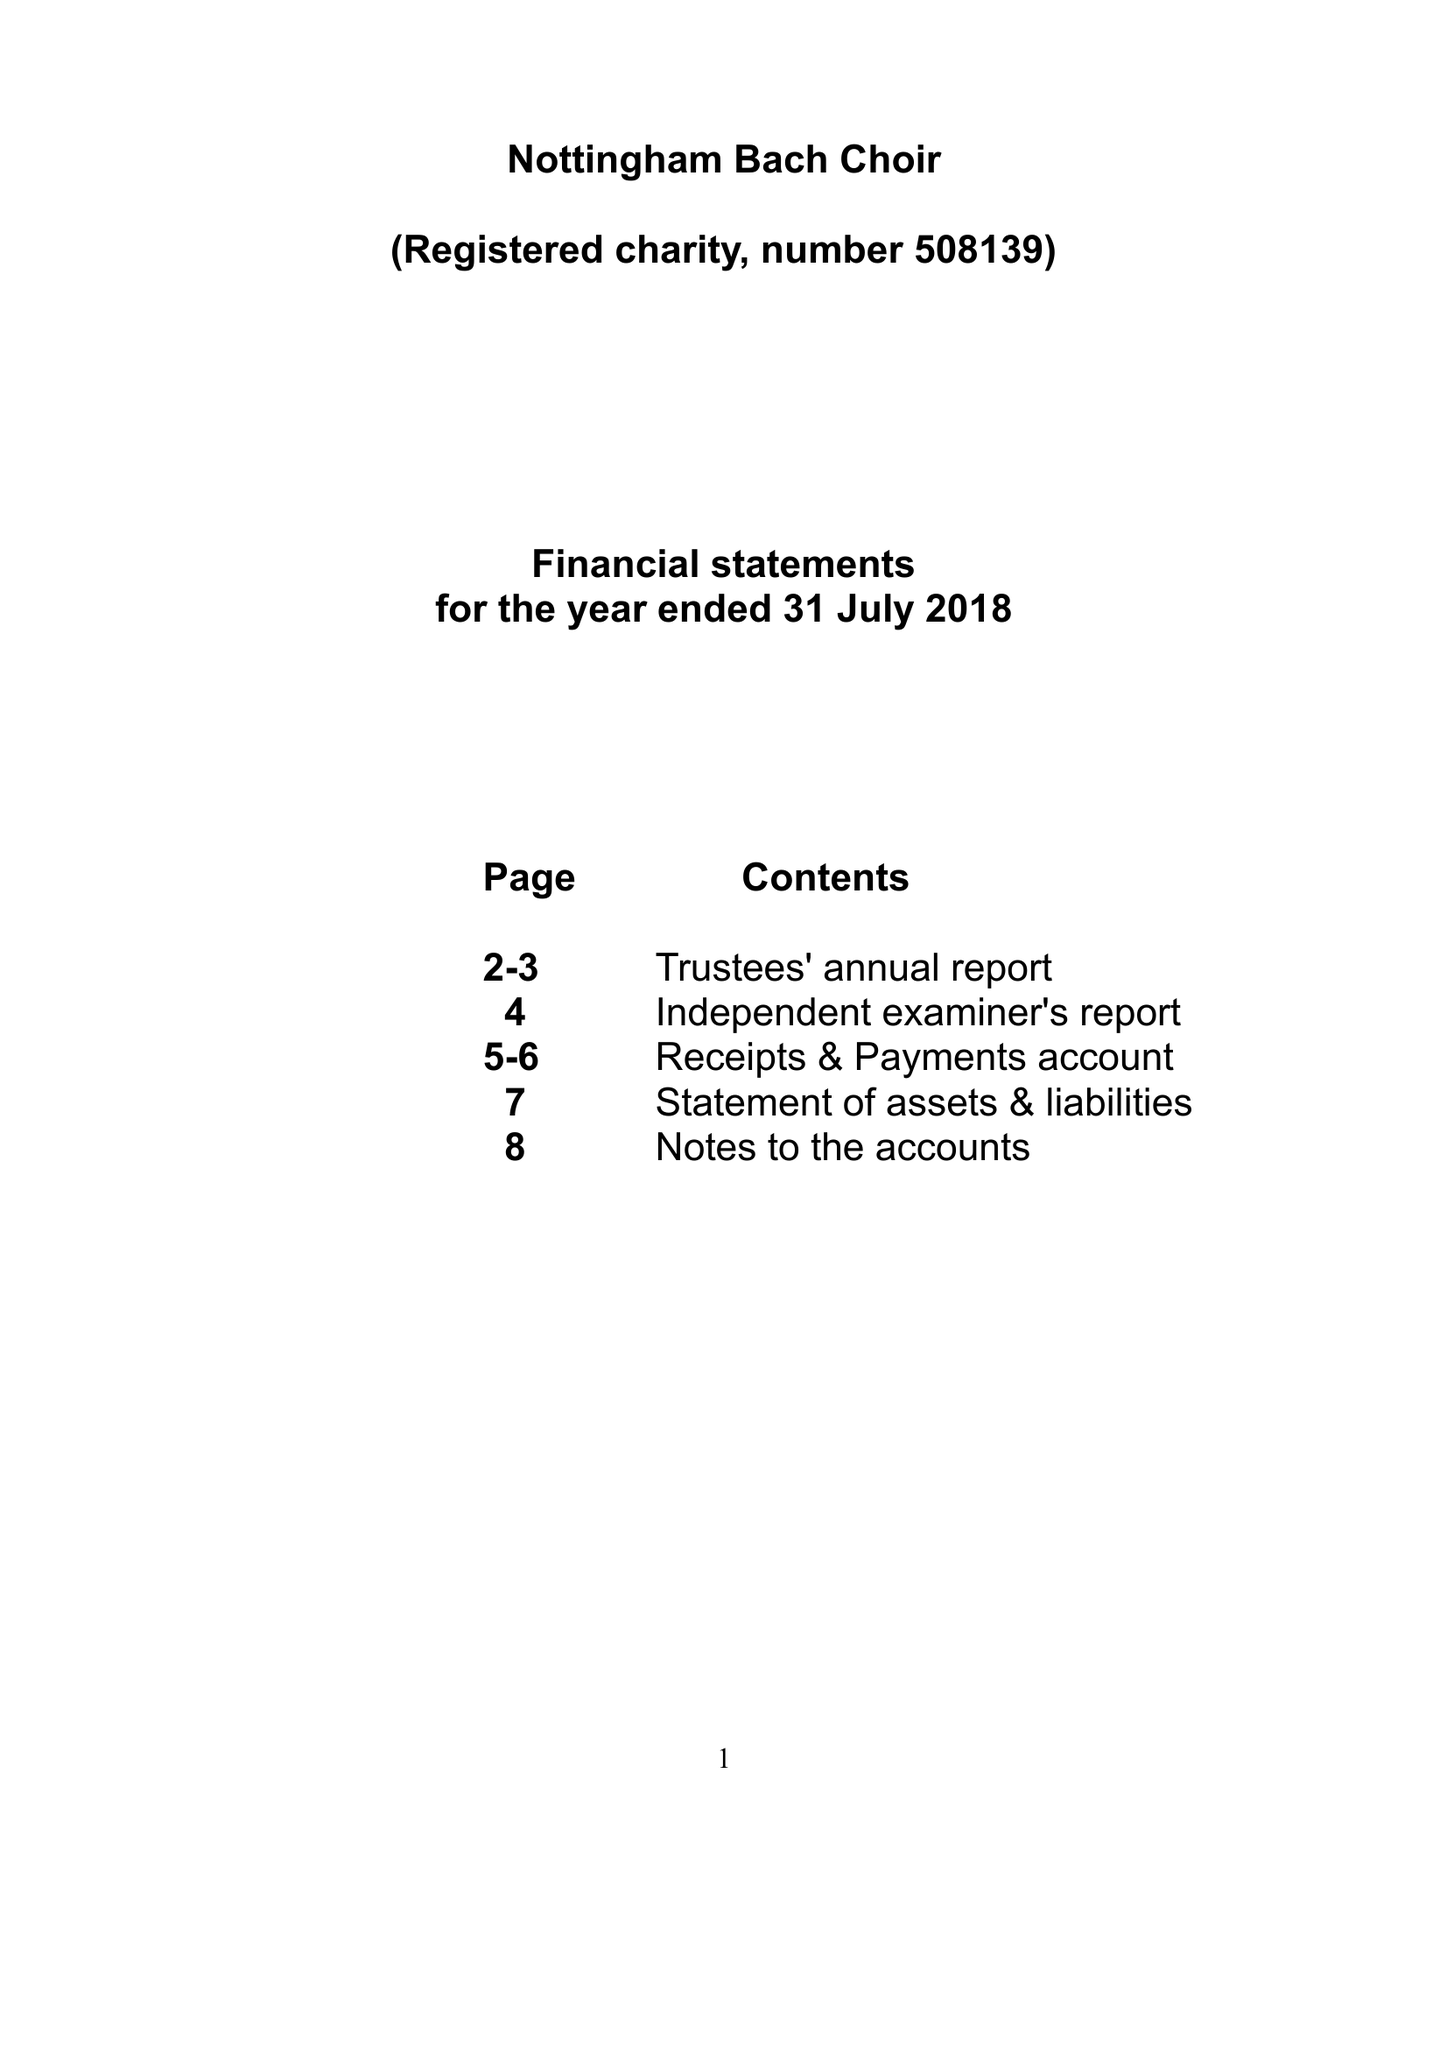What is the value for the address__postcode?
Answer the question using a single word or phrase. LN6 9FH 